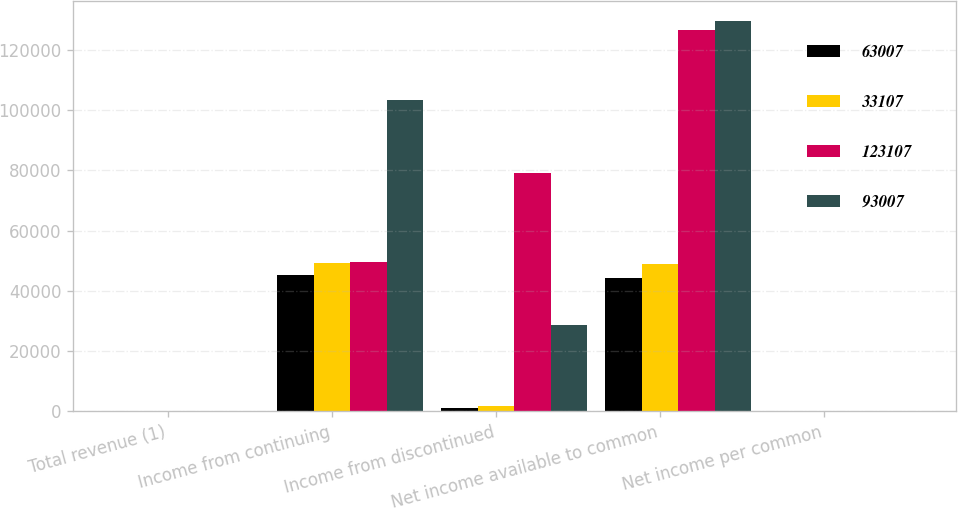<chart> <loc_0><loc_0><loc_500><loc_500><stacked_bar_chart><ecel><fcel>Total revenue (1)<fcel>Income from continuing<fcel>Income from discontinued<fcel>Net income available to common<fcel>Net income per common<nl><fcel>63007<fcel>1.62<fcel>45383<fcel>1137<fcel>44345<fcel>1.45<nl><fcel>33107<fcel>1.62<fcel>49319<fcel>1733<fcel>48877<fcel>0.86<nl><fcel>123107<fcel>1.62<fcel>49677<fcel>79092<fcel>126594<fcel>0.53<nl><fcel>93007<fcel>1.62<fcel>103289<fcel>28530<fcel>129644<fcel>0.58<nl></chart> 